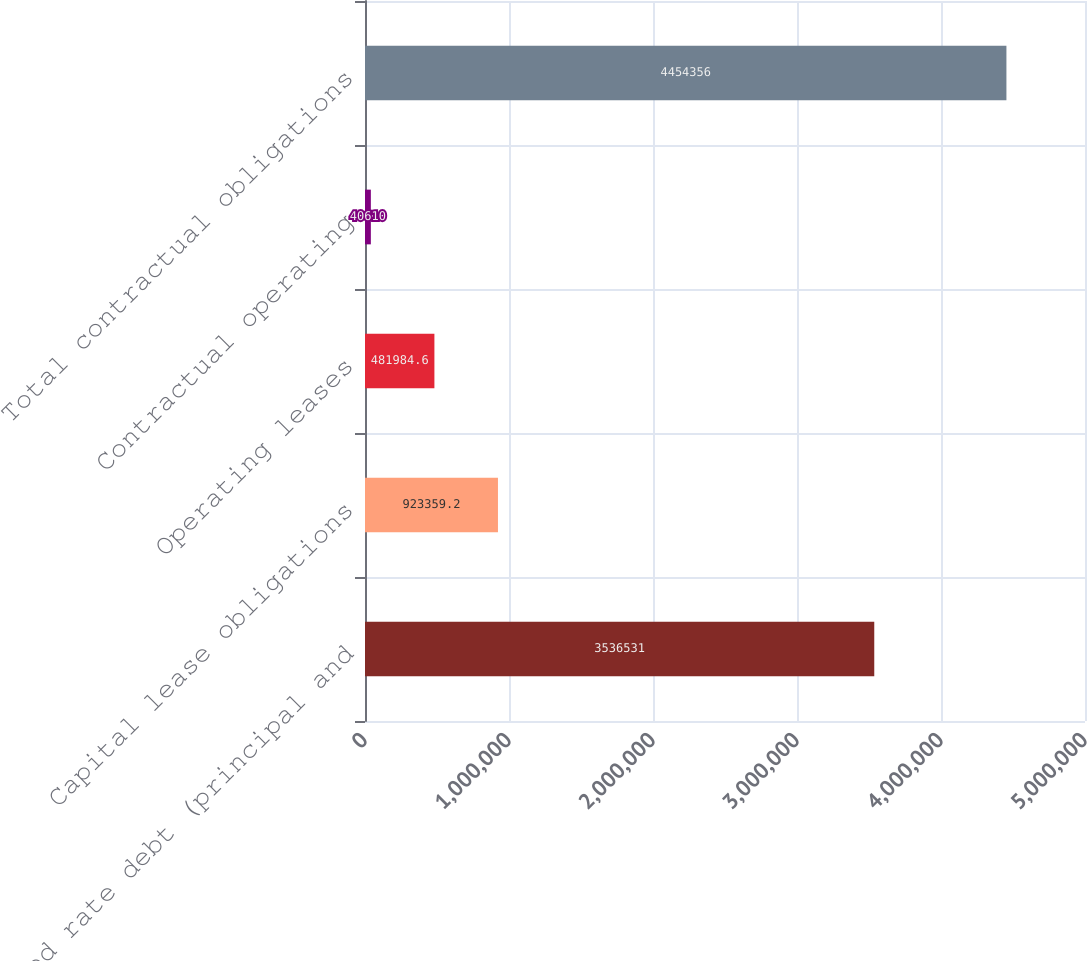Convert chart to OTSL. <chart><loc_0><loc_0><loc_500><loc_500><bar_chart><fcel>Fixed rate debt (principal and<fcel>Capital lease obligations<fcel>Operating leases<fcel>Contractual operating<fcel>Total contractual obligations<nl><fcel>3.53653e+06<fcel>923359<fcel>481985<fcel>40610<fcel>4.45436e+06<nl></chart> 